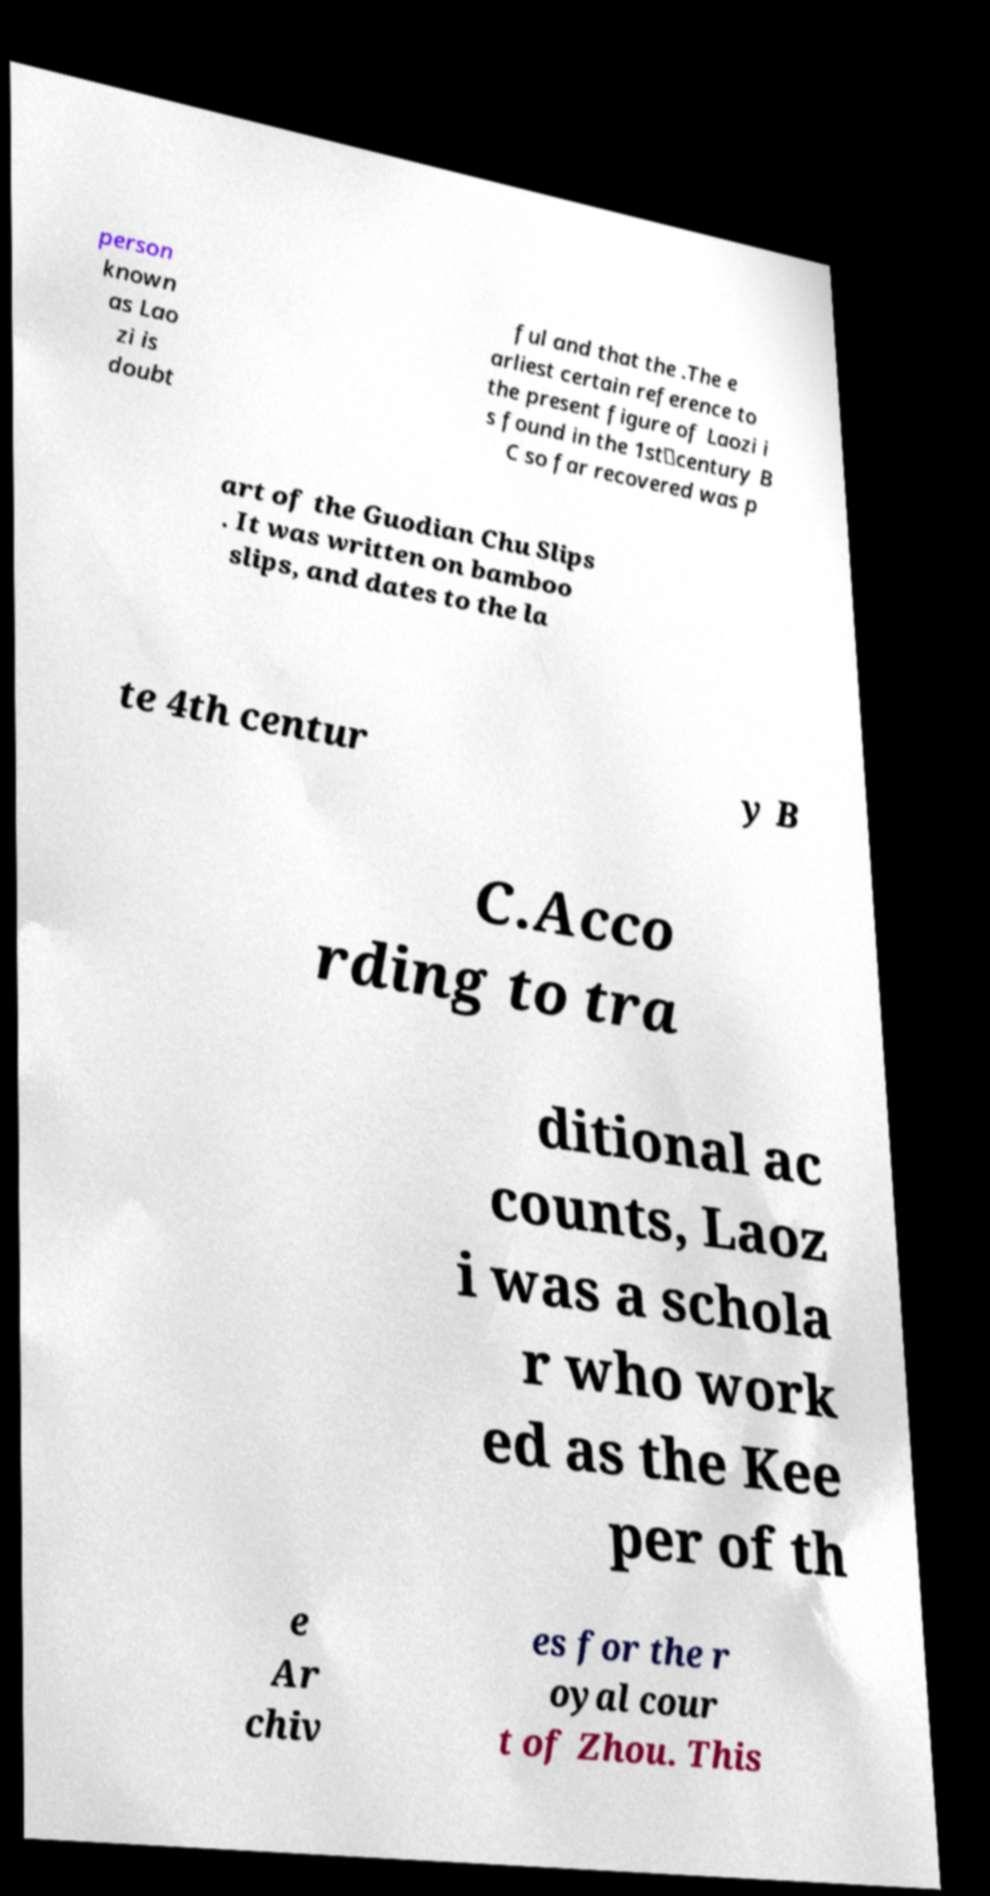What messages or text are displayed in this image? I need them in a readable, typed format. person known as Lao zi is doubt ful and that the .The e arliest certain reference to the present figure of Laozi i s found in the 1st‑century B C so far recovered was p art of the Guodian Chu Slips . It was written on bamboo slips, and dates to the la te 4th centur y B C.Acco rding to tra ditional ac counts, Laoz i was a schola r who work ed as the Kee per of th e Ar chiv es for the r oyal cour t of Zhou. This 